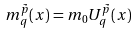Convert formula to latex. <formula><loc_0><loc_0><loc_500><loc_500>m ^ { \tilde { p } } _ { q } ( { x } ) = m _ { 0 } U ^ { \tilde { p } } _ { q } ( { x } )</formula> 